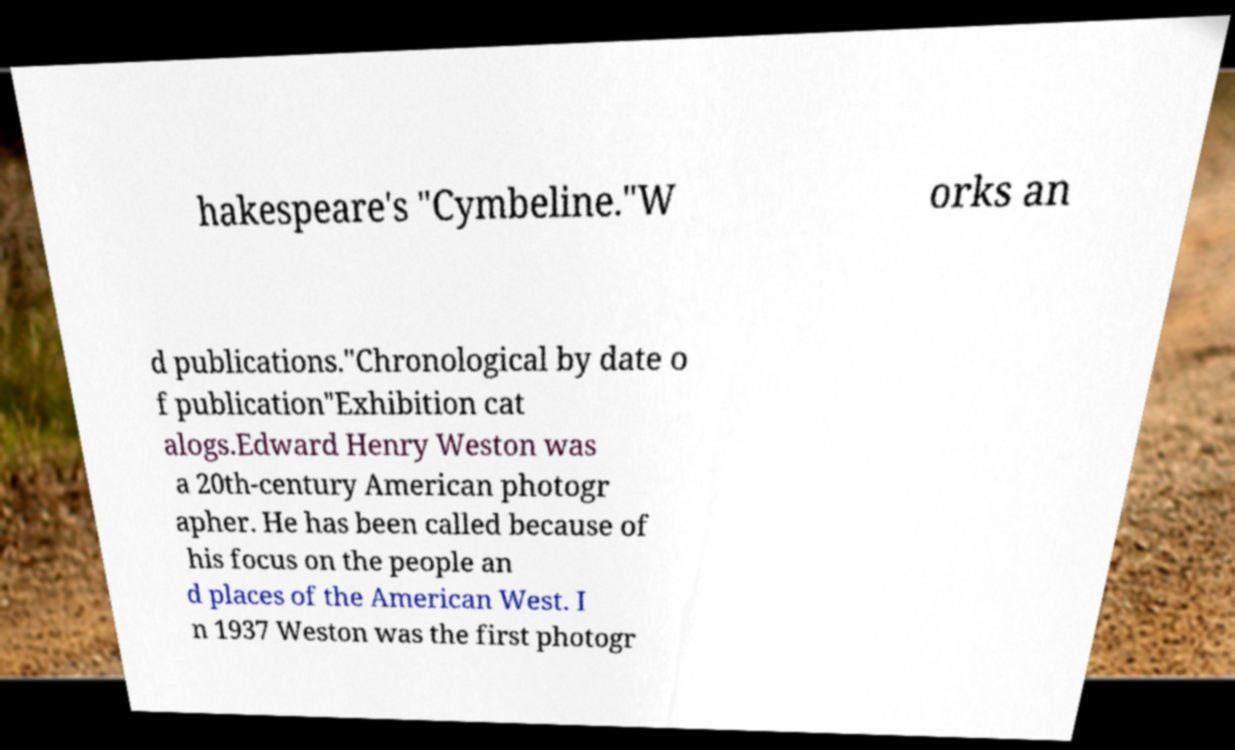Can you read and provide the text displayed in the image?This photo seems to have some interesting text. Can you extract and type it out for me? hakespeare's "Cymbeline."W orks an d publications."Chronological by date o f publication"Exhibition cat alogs.Edward Henry Weston was a 20th-century American photogr apher. He has been called because of his focus on the people an d places of the American West. I n 1937 Weston was the first photogr 